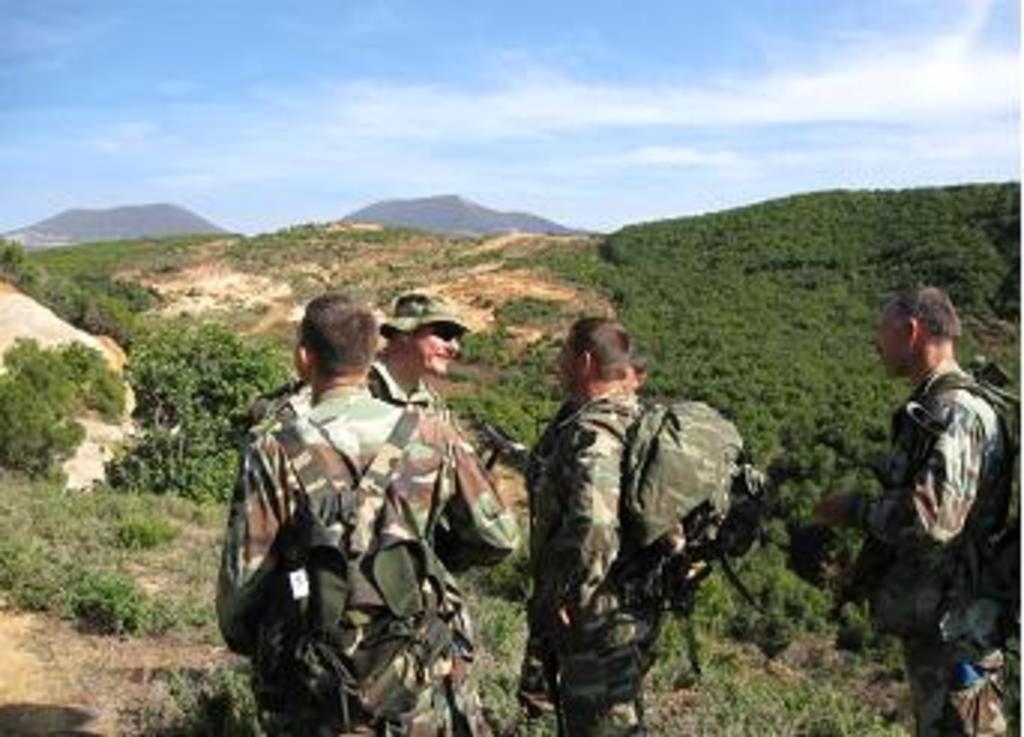In one or two sentences, can you explain what this image depicts? In this image we can see a few people in the uniform wearing bags in which one of them is wearing a hat and goggles, there we can see few trees, mountains and a few clouds in the sky. 